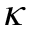Convert formula to latex. <formula><loc_0><loc_0><loc_500><loc_500>\kappa</formula> 